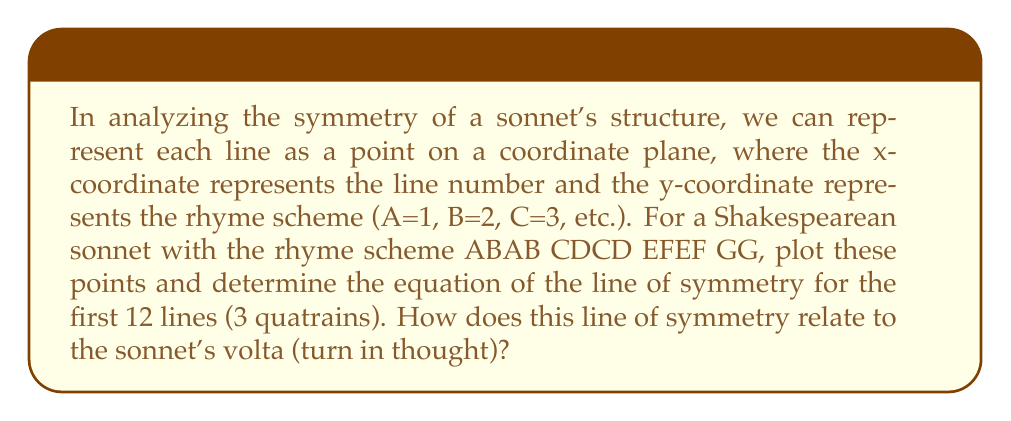Can you solve this math problem? Let's approach this step-by-step:

1) First, we need to plot the points representing each line of the sonnet:

   $$(1,1), (2,2), (3,1), (4,2)$$ for the first quatrain
   $$(5,3), (6,4), (7,3), (8,4)$$ for the second quatrain
   $$(9,5), (10,6), (11,5), (12,6)$$ for the third quatrain

2) We can visualize this using Asymptote:

[asy]
size(200);
for(int i=0; i<12; ++i) {
  dot((i+1, 1+(i%2)+(i/4)*2));
}
xaxis("Line number", 0, 13, arrow=Arrow);
yaxis("Rhyme scheme", 0, 7, arrow=Arrow);
label("A", (0,1), W);
label("B", (0,2), W);
label("C", (0,3), W);
label("D", (0,4), W);
label("E", (0,5), W);
label("F", (0,6), W);
[/asy]

3) The line of symmetry for the first 12 lines would be vertical and pass through the midpoint between lines 6 and 7.

4) The equation of this line of symmetry is:

   $$x = 6.5$$

5) This line of symmetry occurs exactly halfway through the three quatrains, which is typically where the volta or turn in thought occurs in a Shakespearean sonnet.

6) The volta marks a shift in the poem's argument or tone, often moving from problem to resolution or from question to answer. The symmetry we've found mathematically aligns with this literary structure.

7) It's worth noting that the final couplet (GG) is not included in this symmetry, which reflects its special role in summarizing or concluding the sonnet.
Answer: The equation of the line of symmetry is $x = 6.5$. This line occurs at the midpoint of the three quatrains, coinciding with the typical location of the volta in a Shakespearean sonnet, thus mathematically representing the poem's structural and thematic turning point. 